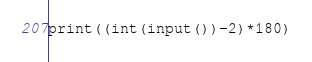Convert code to text. <code><loc_0><loc_0><loc_500><loc_500><_Python_>print((int(input())-2)*180)</code> 